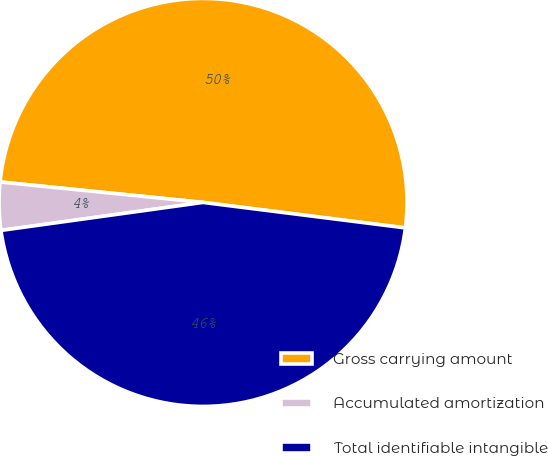Convert chart to OTSL. <chart><loc_0><loc_0><loc_500><loc_500><pie_chart><fcel>Gross carrying amount<fcel>Accumulated amortization<fcel>Total identifiable intangible<nl><fcel>50.39%<fcel>3.79%<fcel>45.81%<nl></chart> 